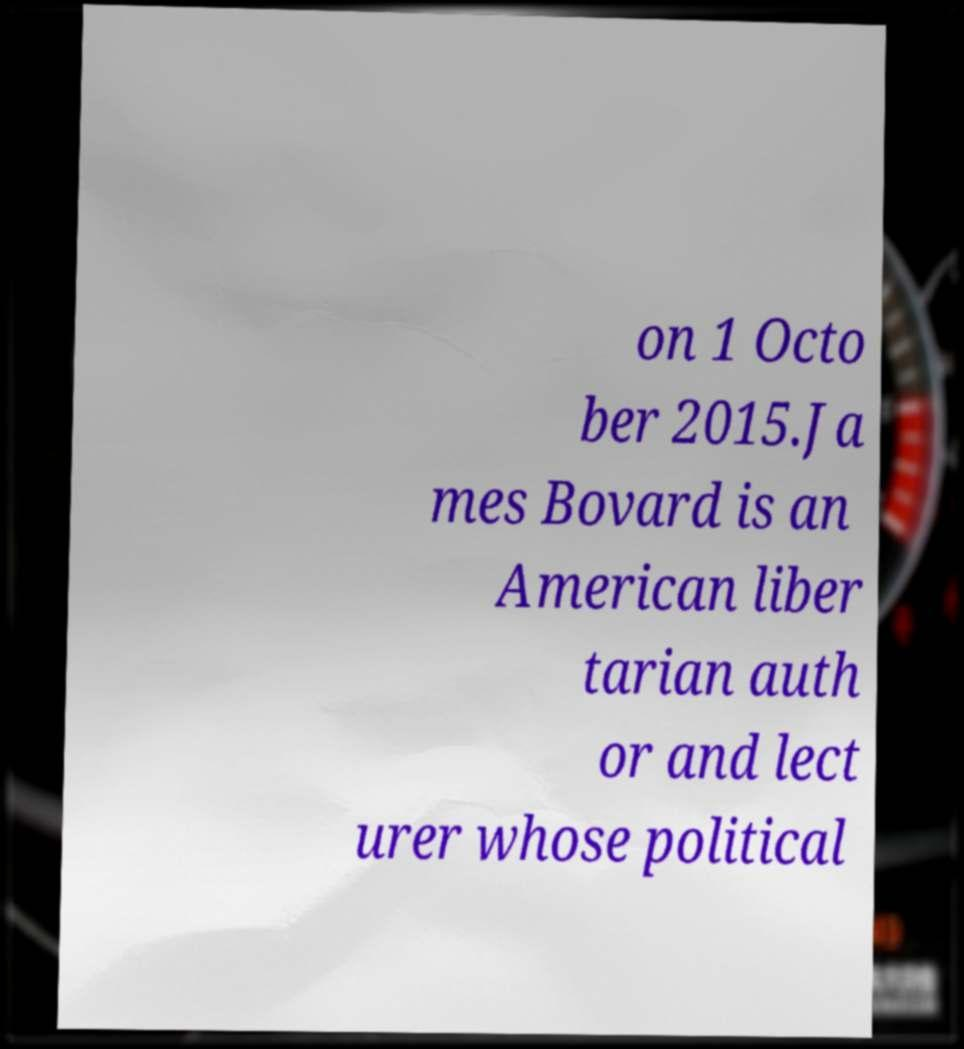There's text embedded in this image that I need extracted. Can you transcribe it verbatim? on 1 Octo ber 2015.Ja mes Bovard is an American liber tarian auth or and lect urer whose political 